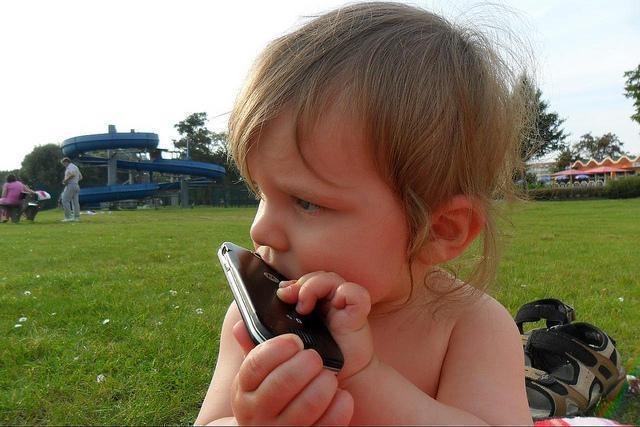What is the baby doing to the phone?
Select the accurate response from the four choices given to answer the question.
Options: Eating, pressing buttons, staring at, throwing. Eating. 